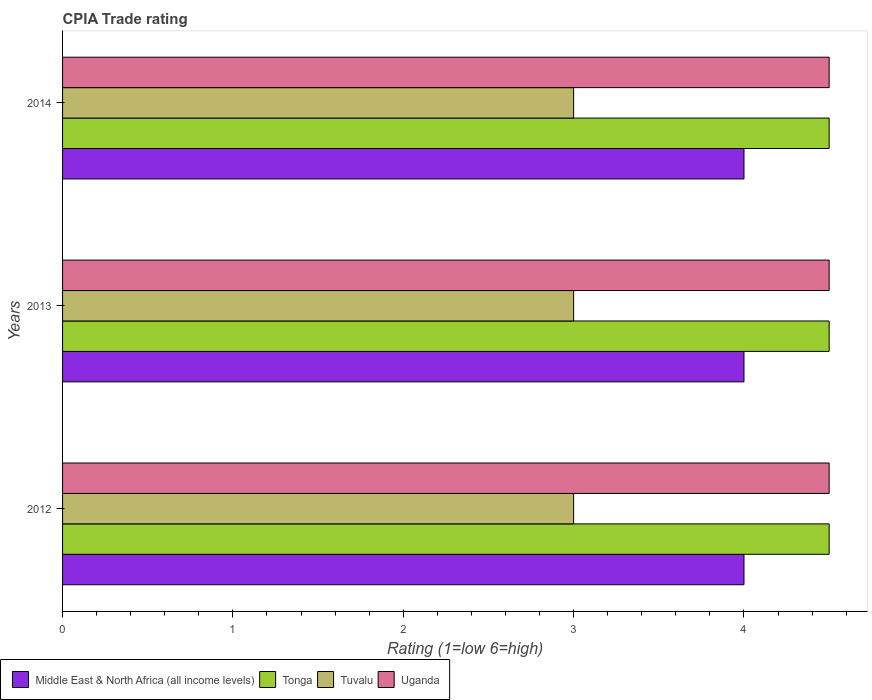How many groups of bars are there?
Your answer should be very brief. 3. Are the number of bars on each tick of the Y-axis equal?
Make the answer very short. Yes. How many bars are there on the 2nd tick from the top?
Provide a short and direct response. 4. What is the label of the 3rd group of bars from the top?
Ensure brevity in your answer.  2012. In how many cases, is the number of bars for a given year not equal to the number of legend labels?
Your answer should be compact. 0. Across all years, what is the maximum CPIA rating in Tonga?
Your response must be concise. 4.5. In which year was the CPIA rating in Tonga minimum?
Your answer should be compact. 2012. In the year 2014, what is the difference between the CPIA rating in Tonga and CPIA rating in Middle East & North Africa (all income levels)?
Make the answer very short. 0.5. In how many years, is the CPIA rating in Uganda greater than 2.2 ?
Keep it short and to the point. 3. What is the ratio of the CPIA rating in Tonga in 2013 to that in 2014?
Your answer should be very brief. 1. Is the CPIA rating in Tuvalu in 2012 less than that in 2013?
Make the answer very short. No. Is the difference between the CPIA rating in Tonga in 2013 and 2014 greater than the difference between the CPIA rating in Middle East & North Africa (all income levels) in 2013 and 2014?
Ensure brevity in your answer.  No. What is the difference between the highest and the lowest CPIA rating in Tonga?
Your answer should be compact. 0. Is it the case that in every year, the sum of the CPIA rating in Tuvalu and CPIA rating in Tonga is greater than the sum of CPIA rating in Middle East & North Africa (all income levels) and CPIA rating in Uganda?
Make the answer very short. No. What does the 3rd bar from the top in 2014 represents?
Give a very brief answer. Tonga. What does the 4th bar from the bottom in 2013 represents?
Your answer should be compact. Uganda. How many years are there in the graph?
Keep it short and to the point. 3. Are the values on the major ticks of X-axis written in scientific E-notation?
Give a very brief answer. No. Does the graph contain grids?
Provide a short and direct response. No. How many legend labels are there?
Offer a terse response. 4. What is the title of the graph?
Offer a very short reply. CPIA Trade rating. Does "Zimbabwe" appear as one of the legend labels in the graph?
Keep it short and to the point. No. What is the label or title of the X-axis?
Provide a short and direct response. Rating (1=low 6=high). What is the Rating (1=low 6=high) of Middle East & North Africa (all income levels) in 2012?
Offer a very short reply. 4. What is the Rating (1=low 6=high) of Tonga in 2012?
Make the answer very short. 4.5. What is the Rating (1=low 6=high) of Tuvalu in 2012?
Your answer should be very brief. 3. What is the Rating (1=low 6=high) in Middle East & North Africa (all income levels) in 2013?
Ensure brevity in your answer.  4. What is the Rating (1=low 6=high) in Uganda in 2013?
Your answer should be very brief. 4.5. What is the Rating (1=low 6=high) of Tuvalu in 2014?
Ensure brevity in your answer.  3. What is the Rating (1=low 6=high) in Uganda in 2014?
Make the answer very short. 4.5. Across all years, what is the minimum Rating (1=low 6=high) of Uganda?
Offer a very short reply. 4.5. What is the total Rating (1=low 6=high) of Middle East & North Africa (all income levels) in the graph?
Provide a short and direct response. 12. What is the total Rating (1=low 6=high) in Tonga in the graph?
Your response must be concise. 13.5. What is the total Rating (1=low 6=high) in Tuvalu in the graph?
Ensure brevity in your answer.  9. What is the total Rating (1=low 6=high) of Uganda in the graph?
Offer a terse response. 13.5. What is the difference between the Rating (1=low 6=high) in Tuvalu in 2012 and that in 2013?
Your answer should be very brief. 0. What is the difference between the Rating (1=low 6=high) of Uganda in 2012 and that in 2013?
Provide a short and direct response. 0. What is the difference between the Rating (1=low 6=high) of Middle East & North Africa (all income levels) in 2012 and that in 2014?
Your response must be concise. 0. What is the difference between the Rating (1=low 6=high) in Uganda in 2012 and that in 2014?
Offer a very short reply. 0. What is the difference between the Rating (1=low 6=high) of Middle East & North Africa (all income levels) in 2013 and that in 2014?
Your answer should be very brief. 0. What is the difference between the Rating (1=low 6=high) in Middle East & North Africa (all income levels) in 2012 and the Rating (1=low 6=high) in Uganda in 2013?
Give a very brief answer. -0.5. What is the difference between the Rating (1=low 6=high) of Tonga in 2012 and the Rating (1=low 6=high) of Tuvalu in 2013?
Ensure brevity in your answer.  1.5. What is the difference between the Rating (1=low 6=high) of Middle East & North Africa (all income levels) in 2012 and the Rating (1=low 6=high) of Tuvalu in 2014?
Provide a succinct answer. 1. What is the difference between the Rating (1=low 6=high) in Middle East & North Africa (all income levels) in 2012 and the Rating (1=low 6=high) in Uganda in 2014?
Keep it short and to the point. -0.5. What is the difference between the Rating (1=low 6=high) of Tuvalu in 2012 and the Rating (1=low 6=high) of Uganda in 2014?
Ensure brevity in your answer.  -1.5. What is the difference between the Rating (1=low 6=high) of Middle East & North Africa (all income levels) in 2013 and the Rating (1=low 6=high) of Tonga in 2014?
Make the answer very short. -0.5. What is the difference between the Rating (1=low 6=high) in Middle East & North Africa (all income levels) in 2013 and the Rating (1=low 6=high) in Tuvalu in 2014?
Your answer should be very brief. 1. What is the difference between the Rating (1=low 6=high) in Tuvalu in 2013 and the Rating (1=low 6=high) in Uganda in 2014?
Provide a short and direct response. -1.5. What is the average Rating (1=low 6=high) in Tuvalu per year?
Ensure brevity in your answer.  3. In the year 2012, what is the difference between the Rating (1=low 6=high) of Tonga and Rating (1=low 6=high) of Tuvalu?
Provide a short and direct response. 1.5. In the year 2012, what is the difference between the Rating (1=low 6=high) in Tuvalu and Rating (1=low 6=high) in Uganda?
Your answer should be very brief. -1.5. In the year 2013, what is the difference between the Rating (1=low 6=high) in Middle East & North Africa (all income levels) and Rating (1=low 6=high) in Tonga?
Provide a succinct answer. -0.5. In the year 2013, what is the difference between the Rating (1=low 6=high) in Middle East & North Africa (all income levels) and Rating (1=low 6=high) in Tuvalu?
Offer a terse response. 1. In the year 2013, what is the difference between the Rating (1=low 6=high) of Middle East & North Africa (all income levels) and Rating (1=low 6=high) of Uganda?
Provide a succinct answer. -0.5. In the year 2013, what is the difference between the Rating (1=low 6=high) in Tonga and Rating (1=low 6=high) in Tuvalu?
Your answer should be very brief. 1.5. In the year 2013, what is the difference between the Rating (1=low 6=high) of Tonga and Rating (1=low 6=high) of Uganda?
Give a very brief answer. 0. In the year 2013, what is the difference between the Rating (1=low 6=high) of Tuvalu and Rating (1=low 6=high) of Uganda?
Provide a succinct answer. -1.5. In the year 2014, what is the difference between the Rating (1=low 6=high) of Middle East & North Africa (all income levels) and Rating (1=low 6=high) of Tonga?
Offer a very short reply. -0.5. In the year 2014, what is the difference between the Rating (1=low 6=high) in Middle East & North Africa (all income levels) and Rating (1=low 6=high) in Tuvalu?
Provide a short and direct response. 1. In the year 2014, what is the difference between the Rating (1=low 6=high) in Tonga and Rating (1=low 6=high) in Tuvalu?
Offer a terse response. 1.5. In the year 2014, what is the difference between the Rating (1=low 6=high) in Tonga and Rating (1=low 6=high) in Uganda?
Your answer should be very brief. 0. What is the ratio of the Rating (1=low 6=high) in Middle East & North Africa (all income levels) in 2012 to that in 2013?
Give a very brief answer. 1. What is the ratio of the Rating (1=low 6=high) of Tuvalu in 2012 to that in 2013?
Your answer should be very brief. 1. What is the ratio of the Rating (1=low 6=high) in Uganda in 2012 to that in 2013?
Provide a succinct answer. 1. What is the ratio of the Rating (1=low 6=high) in Middle East & North Africa (all income levels) in 2012 to that in 2014?
Your answer should be very brief. 1. What is the ratio of the Rating (1=low 6=high) in Tonga in 2012 to that in 2014?
Offer a terse response. 1. What is the ratio of the Rating (1=low 6=high) in Uganda in 2012 to that in 2014?
Your response must be concise. 1. What is the ratio of the Rating (1=low 6=high) of Middle East & North Africa (all income levels) in 2013 to that in 2014?
Keep it short and to the point. 1. What is the ratio of the Rating (1=low 6=high) in Uganda in 2013 to that in 2014?
Make the answer very short. 1. What is the difference between the highest and the second highest Rating (1=low 6=high) of Middle East & North Africa (all income levels)?
Keep it short and to the point. 0. What is the difference between the highest and the second highest Rating (1=low 6=high) in Uganda?
Offer a very short reply. 0. What is the difference between the highest and the lowest Rating (1=low 6=high) in Middle East & North Africa (all income levels)?
Your answer should be very brief. 0. What is the difference between the highest and the lowest Rating (1=low 6=high) in Tonga?
Provide a short and direct response. 0. What is the difference between the highest and the lowest Rating (1=low 6=high) in Tuvalu?
Make the answer very short. 0. What is the difference between the highest and the lowest Rating (1=low 6=high) of Uganda?
Provide a succinct answer. 0. 